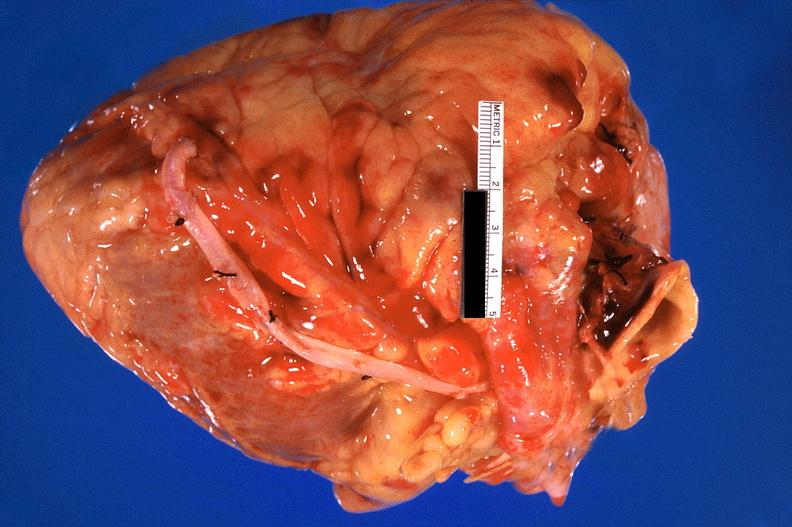what does this image show?
Answer the question using a single word or phrase. Heart 